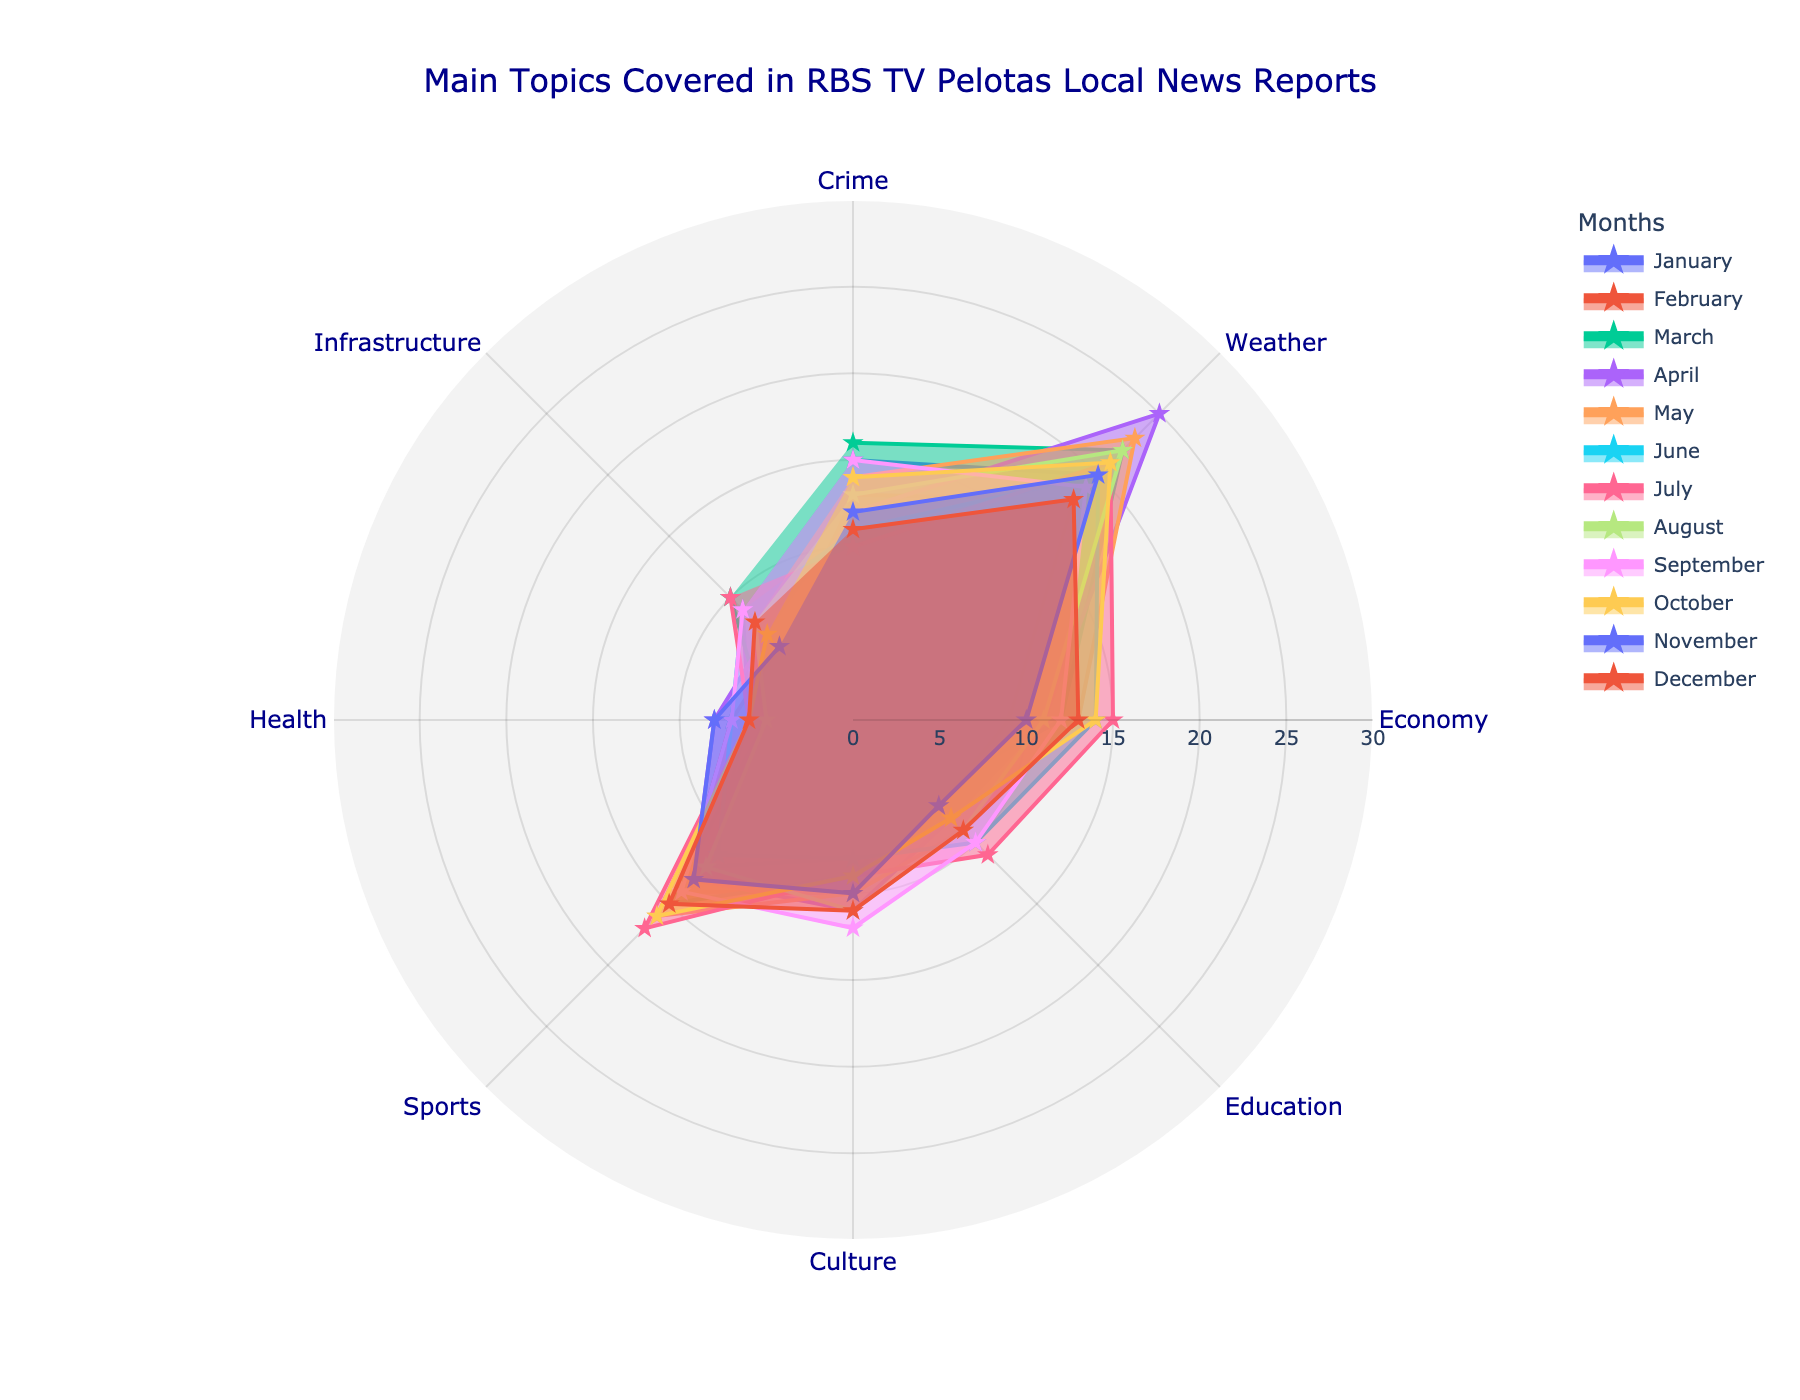What is the main topic with the highest coverage in January? By looking at the radar chart for January, identify the point that is farthest from the center along any axis. This corresponds to the highest coverage value.
Answer: Weather Which month had the lowest coverage in crime reports? Locate the points representing crime coverage for each month on the radar chart. Compare the values to determine the lowest one.
Answer: July What are the main topics covered in August? Examine the points plotted for August on the radar chart and read off the corresponding categories.
Answer: Crime, Weather, Economy, Education, Culture, Sports, Health, Infrastructure What's the average coverage of Education topics over the year? Sum up the coverage values for Education across all months (5+7+6+8+9+10+11+9+10+8+7+9 = 99) and divide by the number of months (12).
Answer: 8.25 Which two months had the same coverage in health topics? Compare the health coverage values for all the months and identify any two months with identical values.
Answer: March and December What topic had a consistent increase in coverage from January to July? Analyze each topic's points trajectory from January to July. A consistent rise will show increasing values over these months.
Answer: Education What's the difference in crime coverage between February and March? Refer to the radar chart for February and March, noting the crime values. Calculate the difference: 16 (March) - 13 (February).
Answer: 3 What month had the most balanced coverage across all main topics? Look for the month where the points on the radar chart are most evenly distributed around the center, indicating similar values for all topics.
Answer: December How does culture coverage in April compare to October? Compare the values for culture coverage in April and October on the radar chart.
Answer: April is higher 